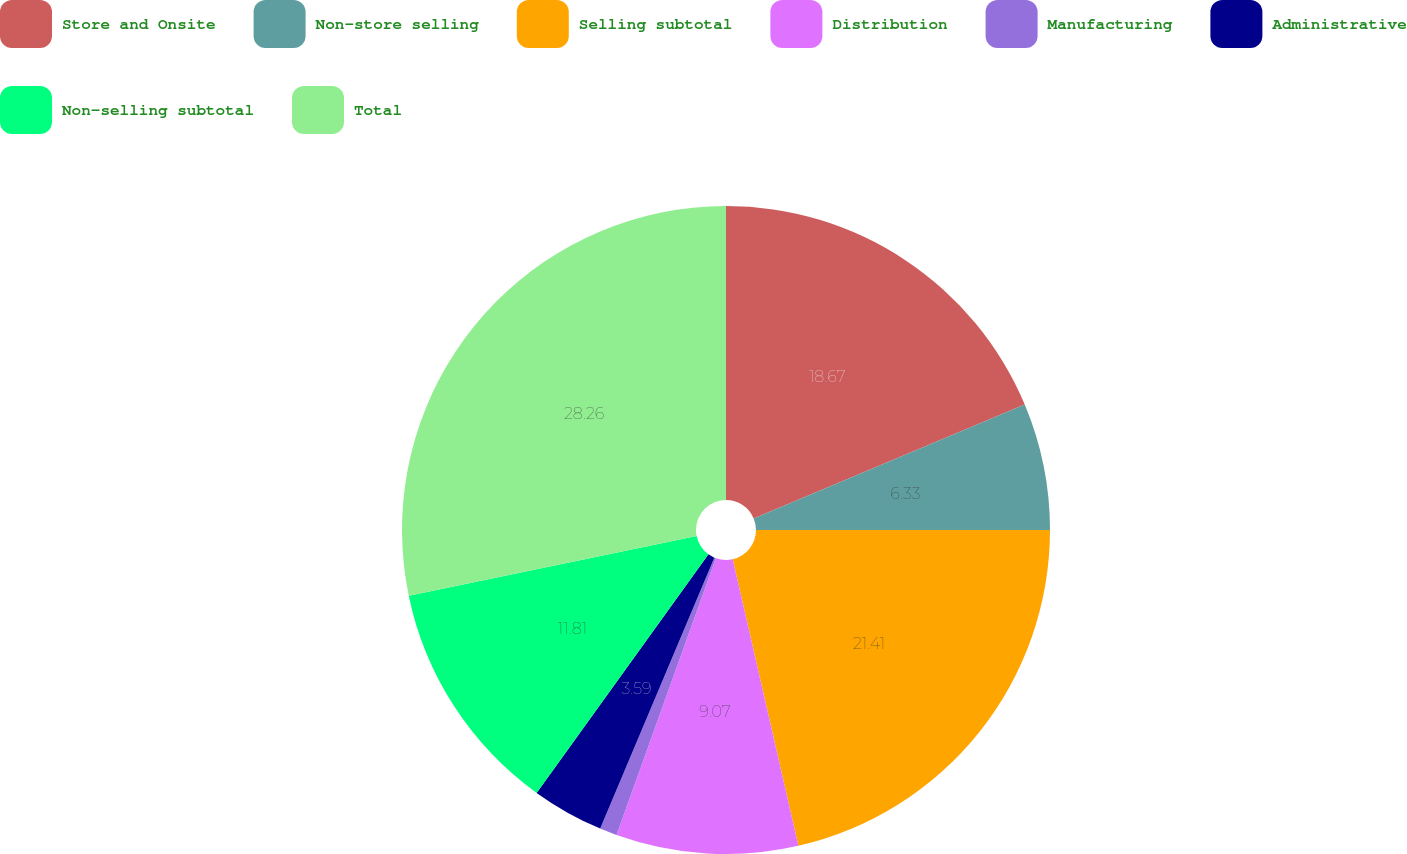Convert chart. <chart><loc_0><loc_0><loc_500><loc_500><pie_chart><fcel>Store and Onsite<fcel>Non-store selling<fcel>Selling subtotal<fcel>Distribution<fcel>Manufacturing<fcel>Administrative<fcel>Non-selling subtotal<fcel>Total<nl><fcel>18.67%<fcel>6.33%<fcel>21.41%<fcel>9.07%<fcel>0.86%<fcel>3.59%<fcel>11.81%<fcel>28.25%<nl></chart> 